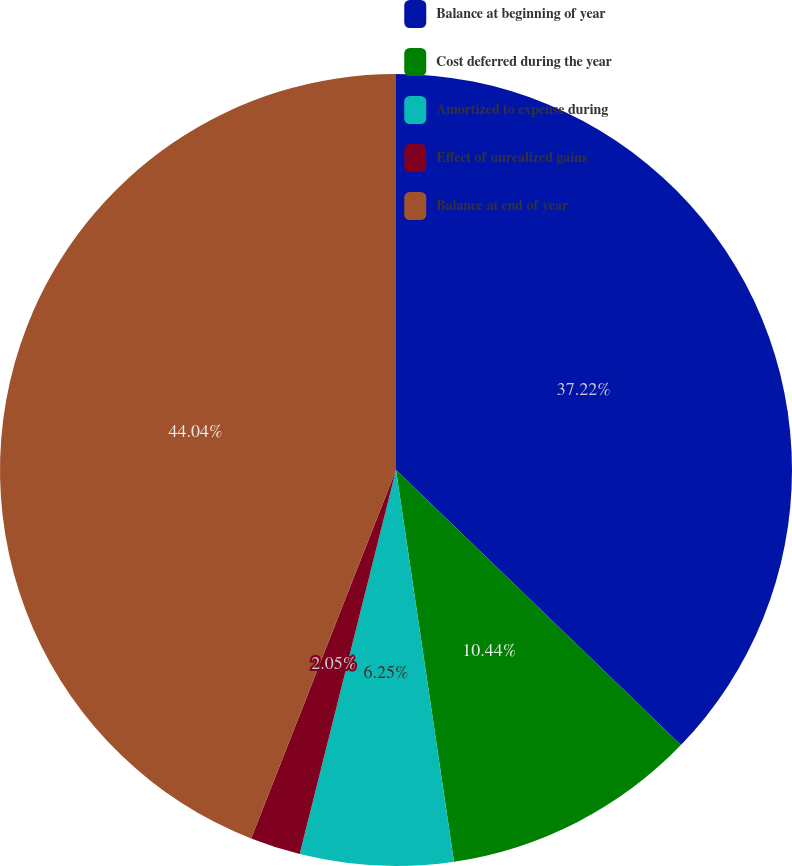Convert chart. <chart><loc_0><loc_0><loc_500><loc_500><pie_chart><fcel>Balance at beginning of year<fcel>Cost deferred during the year<fcel>Amortized to expense during<fcel>Effect of unrealized gains<fcel>Balance at end of year<nl><fcel>37.22%<fcel>10.44%<fcel>6.25%<fcel>2.05%<fcel>44.04%<nl></chart> 